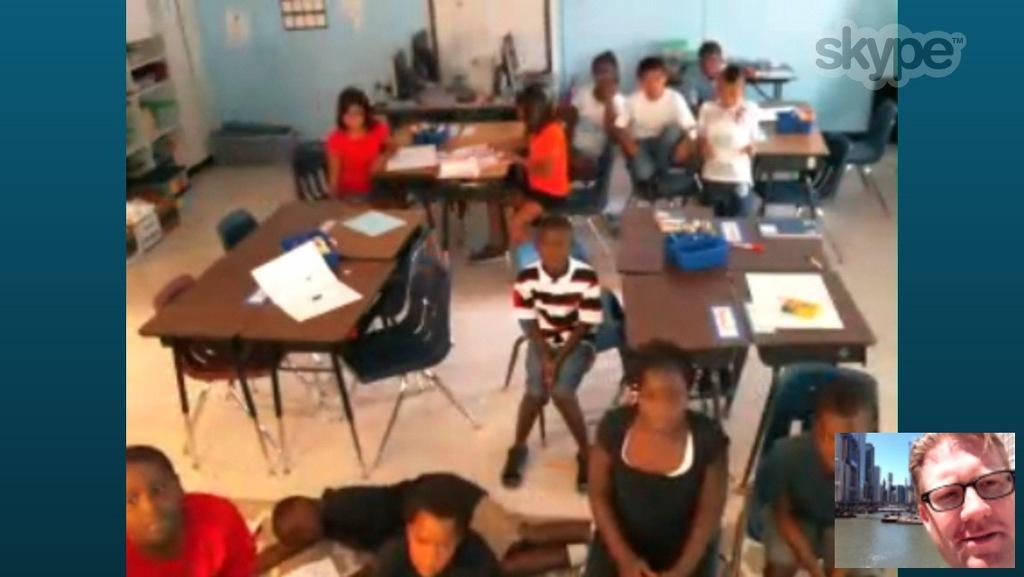How many people are in the image? There is a group of people in the image. What are the people doing in the image? The people are sitting on chairs. What is on the table in the image? There is a paper and some materials on the table. Can you describe the table in the image? There is a table in the image. Who is the expert sitting at the sink in the image? There is no sink or expert present in the image. Who is the creator of the materials on the table in the image? The creator of the materials on the table is not mentioned or visible in the image. 